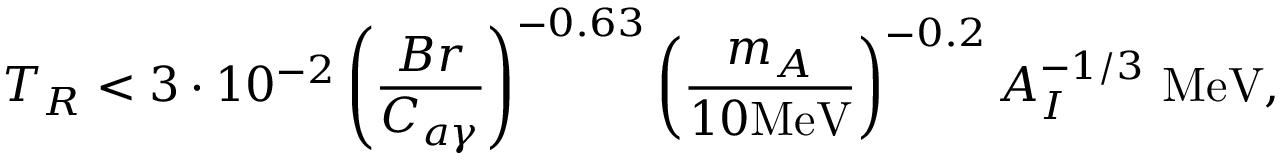<formula> <loc_0><loc_0><loc_500><loc_500>T _ { R } < 3 \cdot 1 0 ^ { - 2 } \left ( \frac { B r } { C _ { a \gamma } } \right ) ^ { - 0 . 6 3 } \left ( \frac { m _ { A } } { 1 0 M e V } \right ) ^ { - 0 . 2 } A _ { I } ^ { - 1 / 3 } M e V ,</formula> 